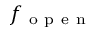Convert formula to latex. <formula><loc_0><loc_0><loc_500><loc_500>f _ { o p e n }</formula> 